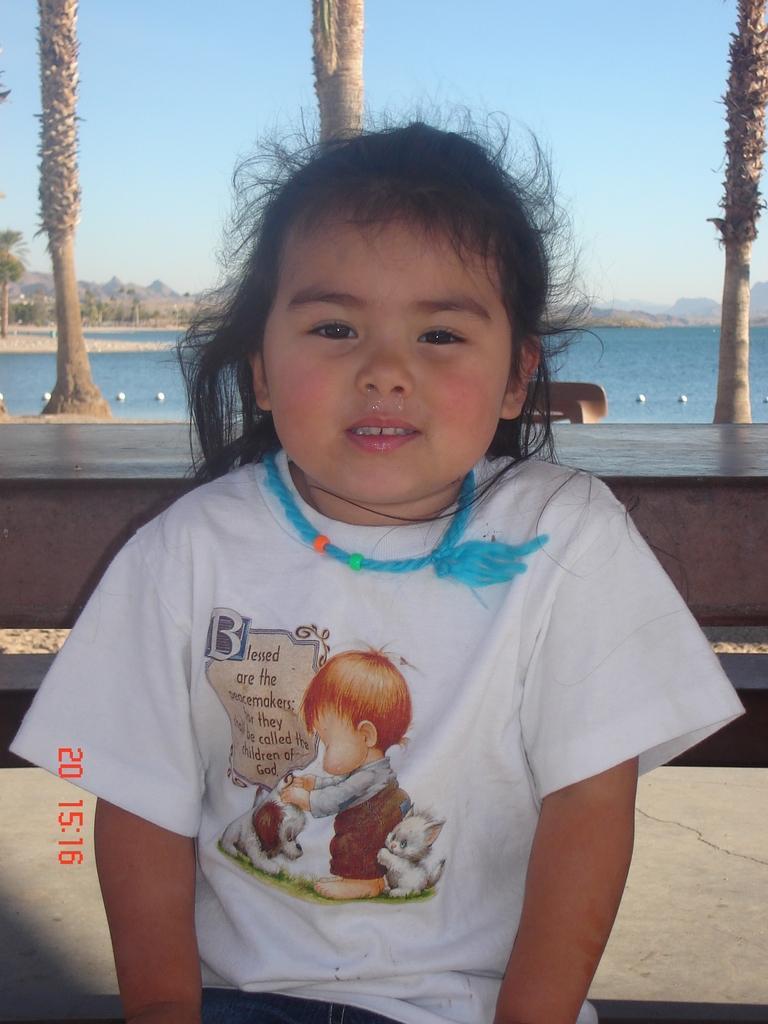Describe this image in one or two sentences. In this image we can see a girl. She is wearing white color dress. Behind trees barks and sea is there. 